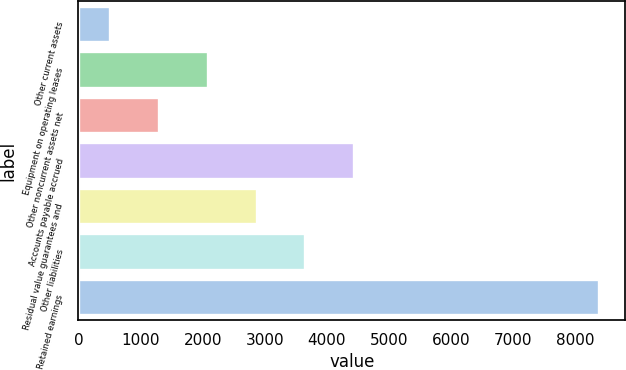Convert chart to OTSL. <chart><loc_0><loc_0><loc_500><loc_500><bar_chart><fcel>Other current assets<fcel>Equipment on operating leases<fcel>Other noncurrent assets net<fcel>Accounts payable accrued<fcel>Residual value guarantees and<fcel>Other liabilities<fcel>Retained earnings<nl><fcel>504.4<fcel>2080.76<fcel>1292.58<fcel>4445.3<fcel>2868.94<fcel>3657.12<fcel>8386.2<nl></chart> 